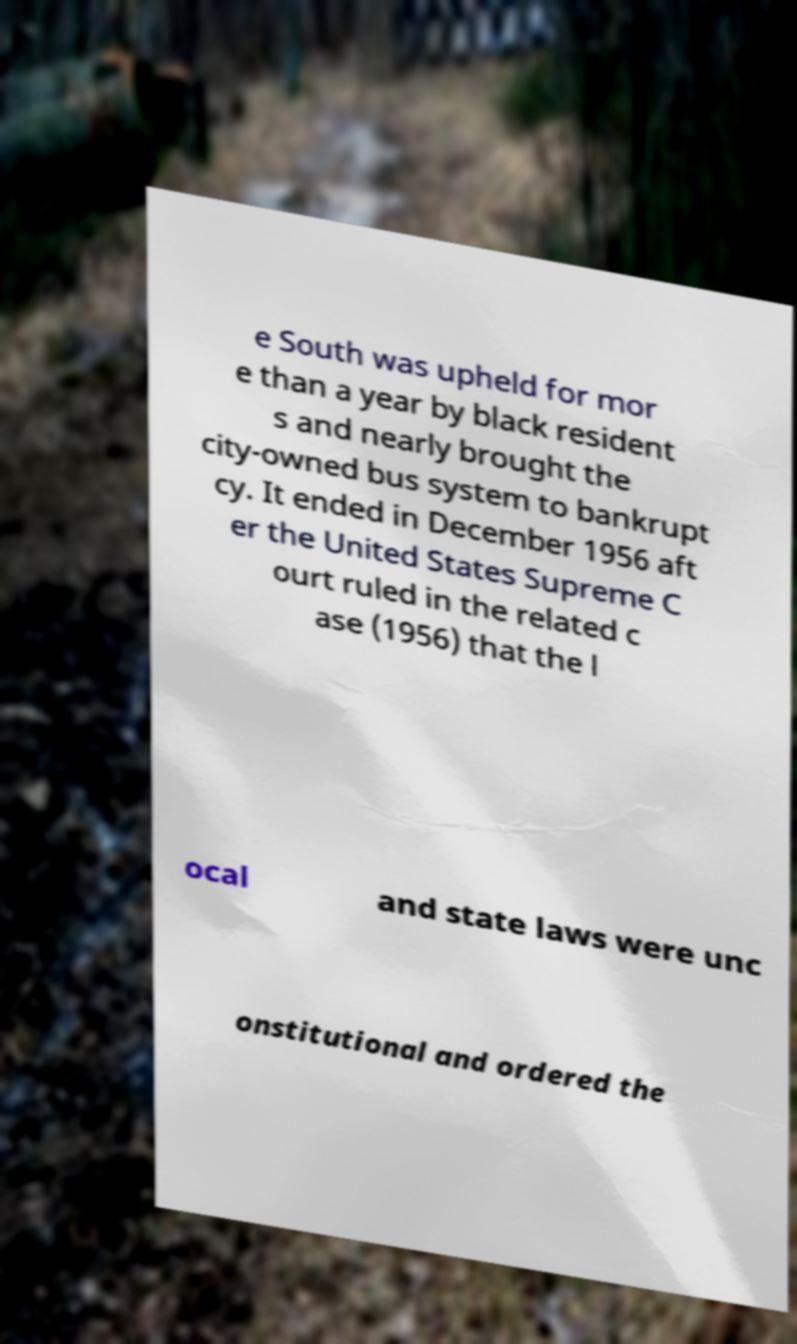Could you extract and type out the text from this image? e South was upheld for mor e than a year by black resident s and nearly brought the city-owned bus system to bankrupt cy. It ended in December 1956 aft er the United States Supreme C ourt ruled in the related c ase (1956) that the l ocal and state laws were unc onstitutional and ordered the 